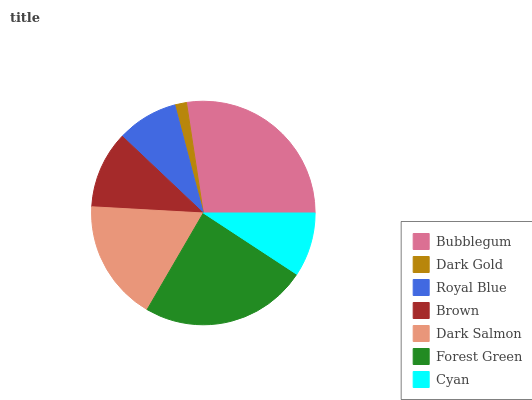Is Dark Gold the minimum?
Answer yes or no. Yes. Is Bubblegum the maximum?
Answer yes or no. Yes. Is Royal Blue the minimum?
Answer yes or no. No. Is Royal Blue the maximum?
Answer yes or no. No. Is Royal Blue greater than Dark Gold?
Answer yes or no. Yes. Is Dark Gold less than Royal Blue?
Answer yes or no. Yes. Is Dark Gold greater than Royal Blue?
Answer yes or no. No. Is Royal Blue less than Dark Gold?
Answer yes or no. No. Is Brown the high median?
Answer yes or no. Yes. Is Brown the low median?
Answer yes or no. Yes. Is Dark Salmon the high median?
Answer yes or no. No. Is Cyan the low median?
Answer yes or no. No. 